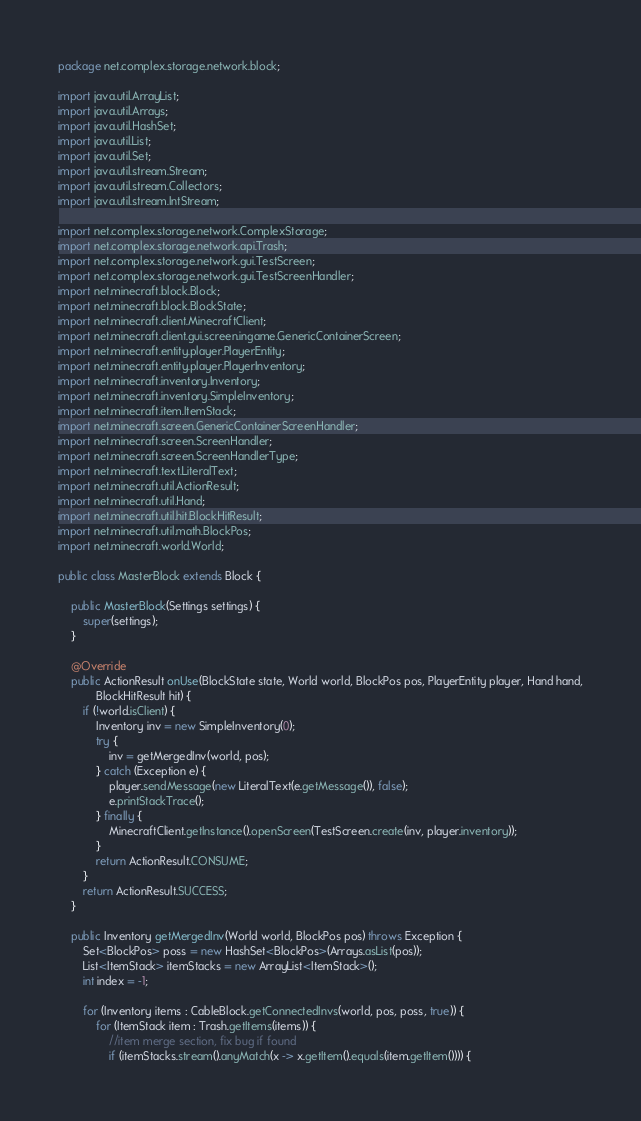Convert code to text. <code><loc_0><loc_0><loc_500><loc_500><_Java_>package net.complex.storage.network.block;

import java.util.ArrayList;
import java.util.Arrays;
import java.util.HashSet;
import java.util.List;
import java.util.Set;
import java.util.stream.Stream;
import java.util.stream.Collectors;
import java.util.stream.IntStream;

import net.complex.storage.network.ComplexStorage;
import net.complex.storage.network.api.Trash;
import net.complex.storage.network.gui.TestScreen;
import net.complex.storage.network.gui.TestScreenHandler;
import net.minecraft.block.Block;
import net.minecraft.block.BlockState;
import net.minecraft.client.MinecraftClient;
import net.minecraft.client.gui.screen.ingame.GenericContainerScreen;
import net.minecraft.entity.player.PlayerEntity;
import net.minecraft.entity.player.PlayerInventory;
import net.minecraft.inventory.Inventory;
import net.minecraft.inventory.SimpleInventory;
import net.minecraft.item.ItemStack;
import net.minecraft.screen.GenericContainerScreenHandler;
import net.minecraft.screen.ScreenHandler;
import net.minecraft.screen.ScreenHandlerType;
import net.minecraft.text.LiteralText;
import net.minecraft.util.ActionResult;
import net.minecraft.util.Hand;
import net.minecraft.util.hit.BlockHitResult;
import net.minecraft.util.math.BlockPos;
import net.minecraft.world.World;

public class MasterBlock extends Block {

    public MasterBlock(Settings settings) {
        super(settings);
    }

    @Override
    public ActionResult onUse(BlockState state, World world, BlockPos pos, PlayerEntity player, Hand hand,
            BlockHitResult hit) {
        if (!world.isClient) {
            Inventory inv = new SimpleInventory(0);
            try {
                inv = getMergedInv(world, pos);
            } catch (Exception e) {
                player.sendMessage(new LiteralText(e.getMessage()), false);
                e.printStackTrace();
            } finally {
                MinecraftClient.getInstance().openScreen(TestScreen.create(inv, player.inventory));
            }
            return ActionResult.CONSUME;
        }
        return ActionResult.SUCCESS;
    }

    public Inventory getMergedInv(World world, BlockPos pos) throws Exception {
        Set<BlockPos> poss = new HashSet<BlockPos>(Arrays.asList(pos));
        List<ItemStack> itemStacks = new ArrayList<ItemStack>();
        int index = -1;

        for (Inventory items : CableBlock.getConnectedInvs(world, pos, poss, true)) {
            for (ItemStack item : Trash.getItems(items)) {
                //item merge section, fix bug if found
                if (itemStacks.stream().anyMatch(x -> x.getItem().equals(item.getItem()))) {</code> 